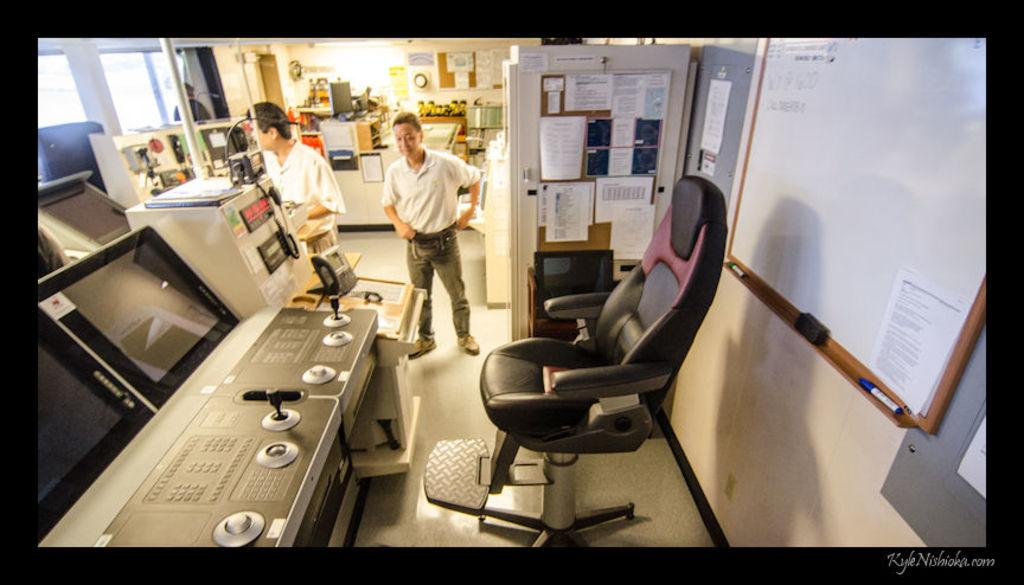Who is present in the image? There is a man in the image. What is the man wearing? The man is wearing a t-shirt, trousers, and shoes. What furniture can be seen in the image? There is a chair in the image. What writing or drawing tool is visible? There is a marker in the image. What surface might be used for writing or drawing? There is a whiteboard in the image. What material is present for recording information? There is paper in the image. What device is present for displaying visuals? There is a screen in the image. What type of powder is being used to create the visuals on the screen? There is no powder present in the image, and the screen is not displaying any visuals that would require powder. 